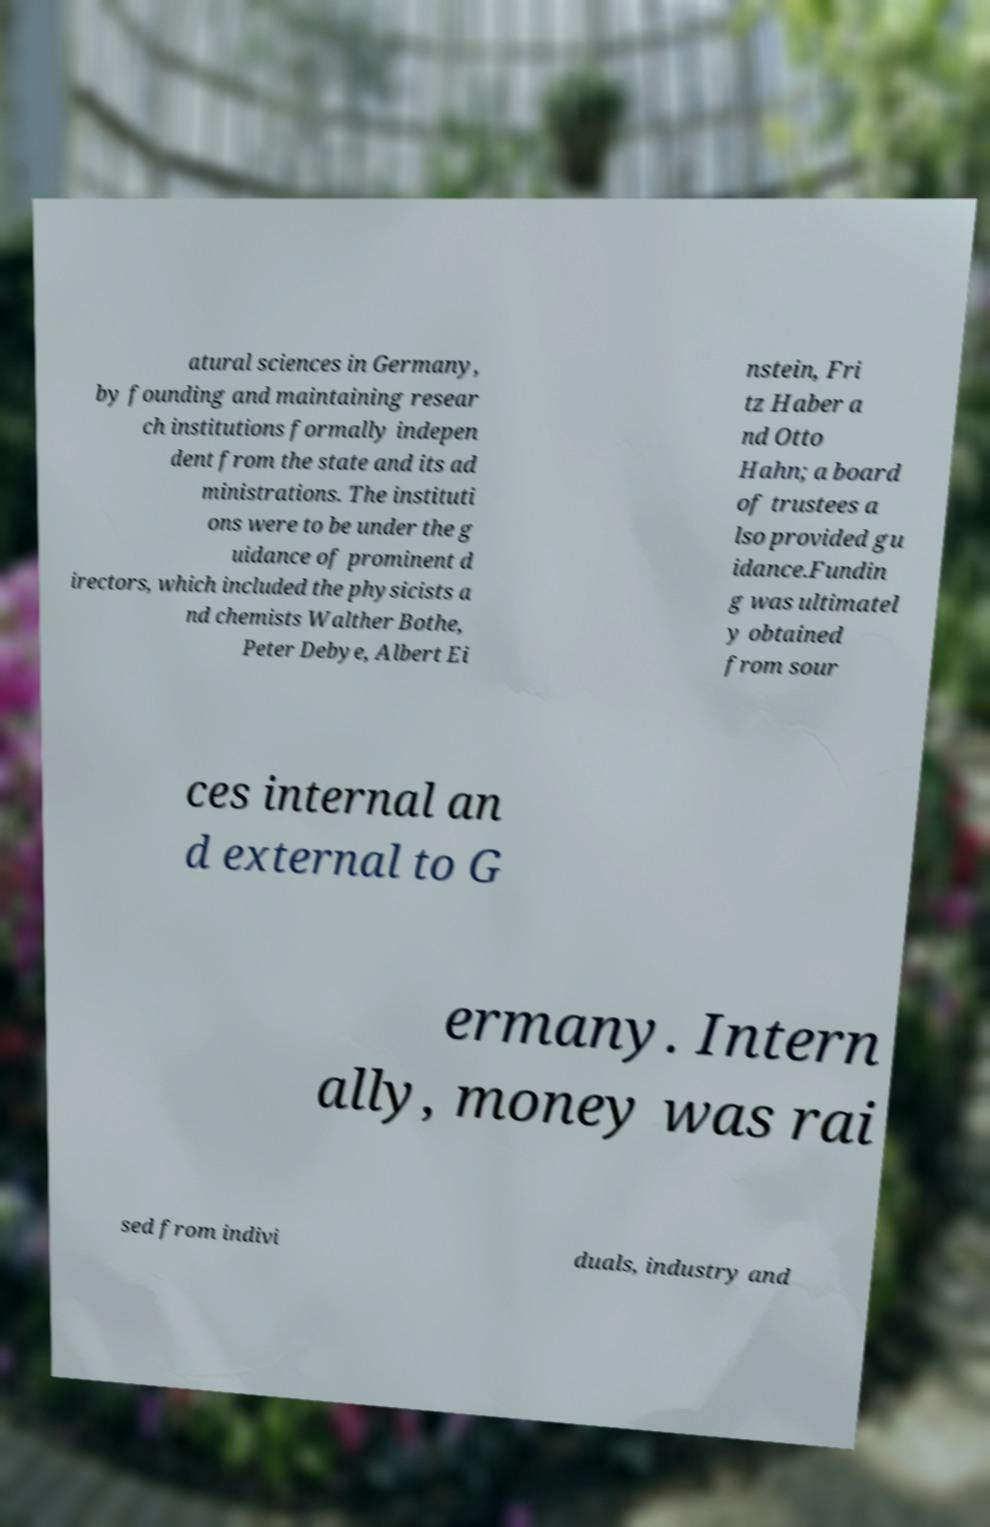Could you assist in decoding the text presented in this image and type it out clearly? atural sciences in Germany, by founding and maintaining resear ch institutions formally indepen dent from the state and its ad ministrations. The instituti ons were to be under the g uidance of prominent d irectors, which included the physicists a nd chemists Walther Bothe, Peter Debye, Albert Ei nstein, Fri tz Haber a nd Otto Hahn; a board of trustees a lso provided gu idance.Fundin g was ultimatel y obtained from sour ces internal an d external to G ermany. Intern ally, money was rai sed from indivi duals, industry and 